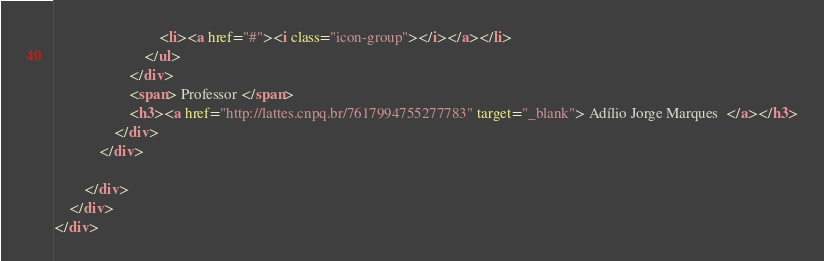Convert code to text. <code><loc_0><loc_0><loc_500><loc_500><_HTML_>							<li><a href="#"><i class="icon-group"></i></a></li>
						</ul>
					</div>
					<span> Professor </span>
					<h3><a href="http://lattes.cnpq.br/7617994755277783" target="_blank"> Adílio Jorge Marques  </a></h3>
				</div>
			</div>

		</div>
	</div>
</div></code> 